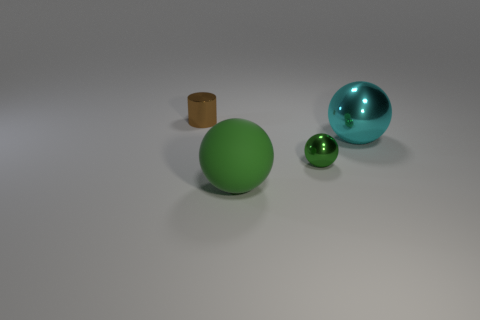What shape is the shiny thing that is the same color as the large rubber ball?
Give a very brief answer. Sphere. How many things are either metal things that are in front of the tiny cylinder or small things that are in front of the brown shiny cylinder?
Give a very brief answer. 2. Are the large cyan ball and the large sphere in front of the large cyan metallic ball made of the same material?
Keep it short and to the point. No. What number of other things are there of the same shape as the brown object?
Your answer should be very brief. 0. There is a big ball that is on the left side of the large ball on the right side of the small object in front of the brown cylinder; what is its material?
Ensure brevity in your answer.  Rubber. Are there the same number of green balls behind the tiny cylinder and blue shiny balls?
Your response must be concise. Yes. Do the object left of the big matte thing and the big object on the right side of the tiny green ball have the same material?
Make the answer very short. Yes. Are there any other things that have the same material as the large green object?
Provide a short and direct response. No. There is a small shiny thing that is in front of the small brown metallic cylinder; does it have the same shape as the big thing that is in front of the cyan shiny object?
Your response must be concise. Yes. Are there fewer green objects that are behind the brown object than yellow rubber things?
Offer a very short reply. No. 